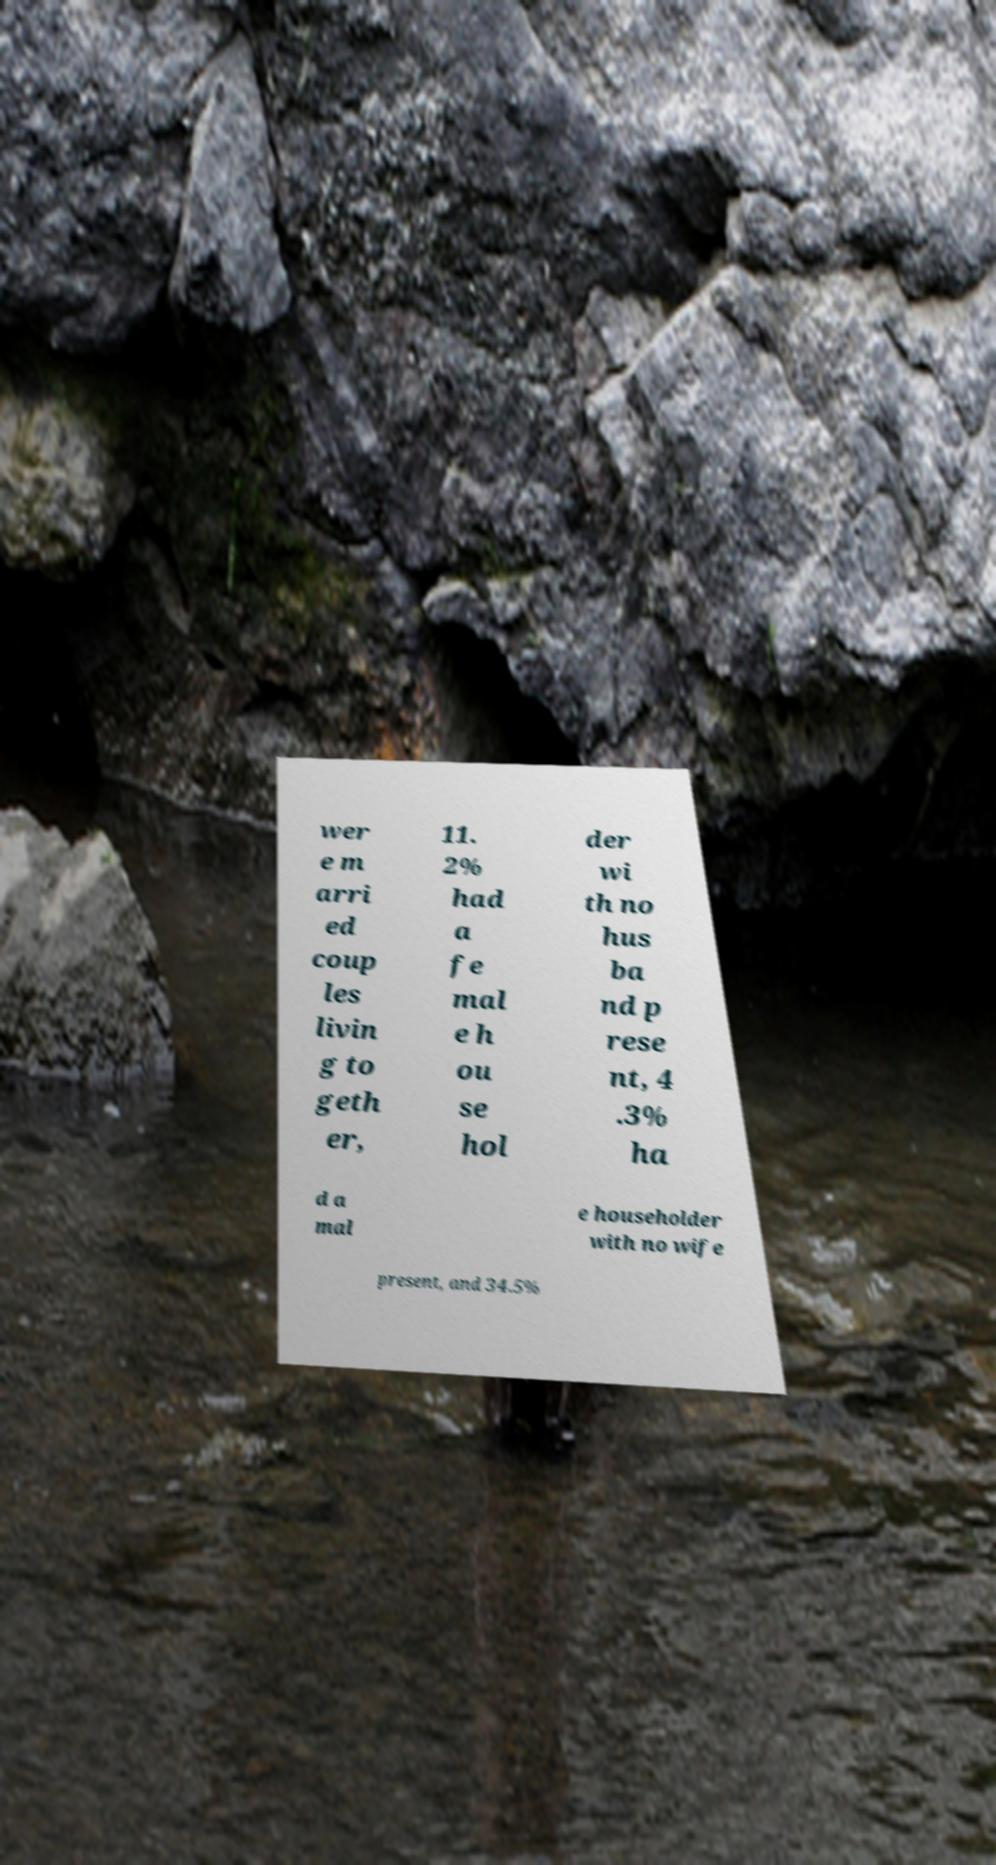Please read and relay the text visible in this image. What does it say? wer e m arri ed coup les livin g to geth er, 11. 2% had a fe mal e h ou se hol der wi th no hus ba nd p rese nt, 4 .3% ha d a mal e householder with no wife present, and 34.5% 